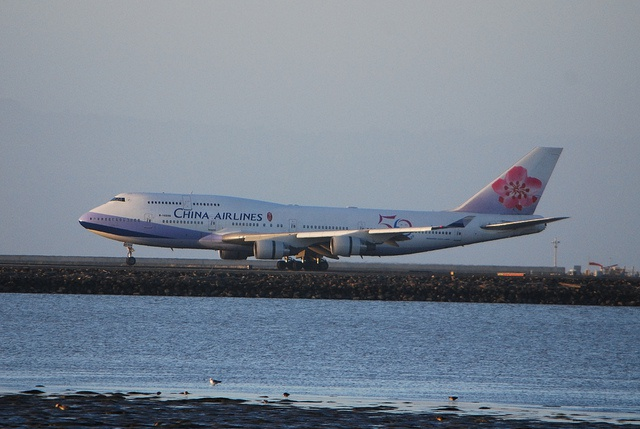Describe the objects in this image and their specific colors. I can see airplane in darkgray, gray, and black tones, bird in darkgray, black, gray, and navy tones, bird in darkgray, black, maroon, and gray tones, bird in darkgray, black, gray, and tan tones, and bird in darkgray, black, maroon, gray, and brown tones in this image. 